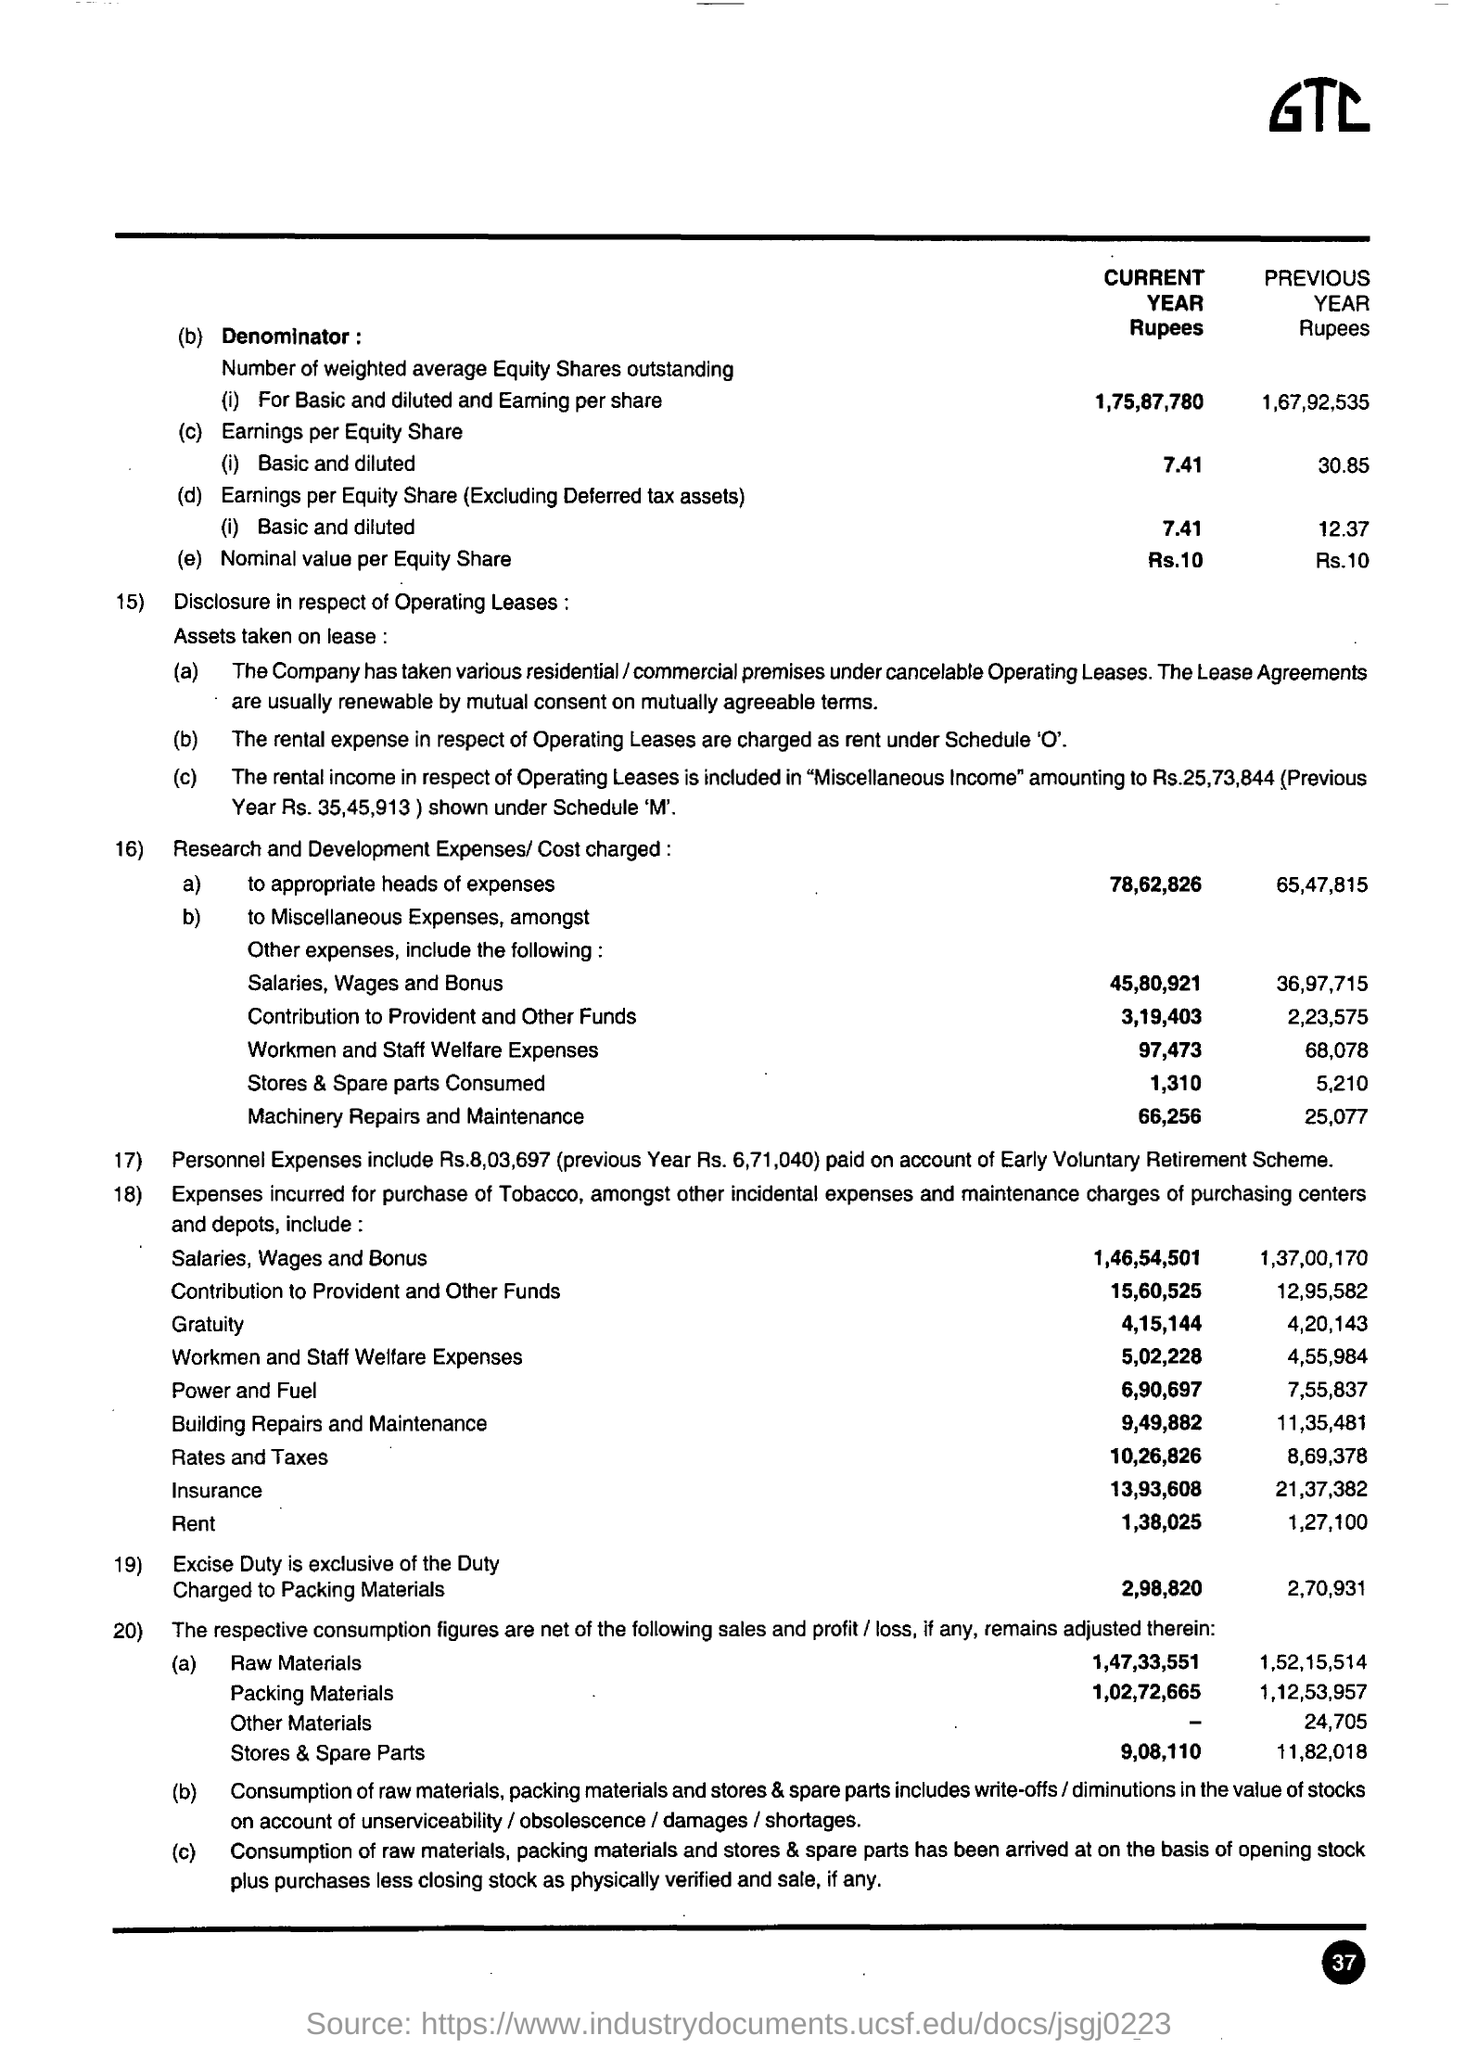What is the nominal value per equity share for the current year rupees ?
Ensure brevity in your answer.  Rs. 10. For the number of weighted average equity shares outstanding for basic and diluted and earning per share for current year ?
Your response must be concise. 1,75,87,780. 